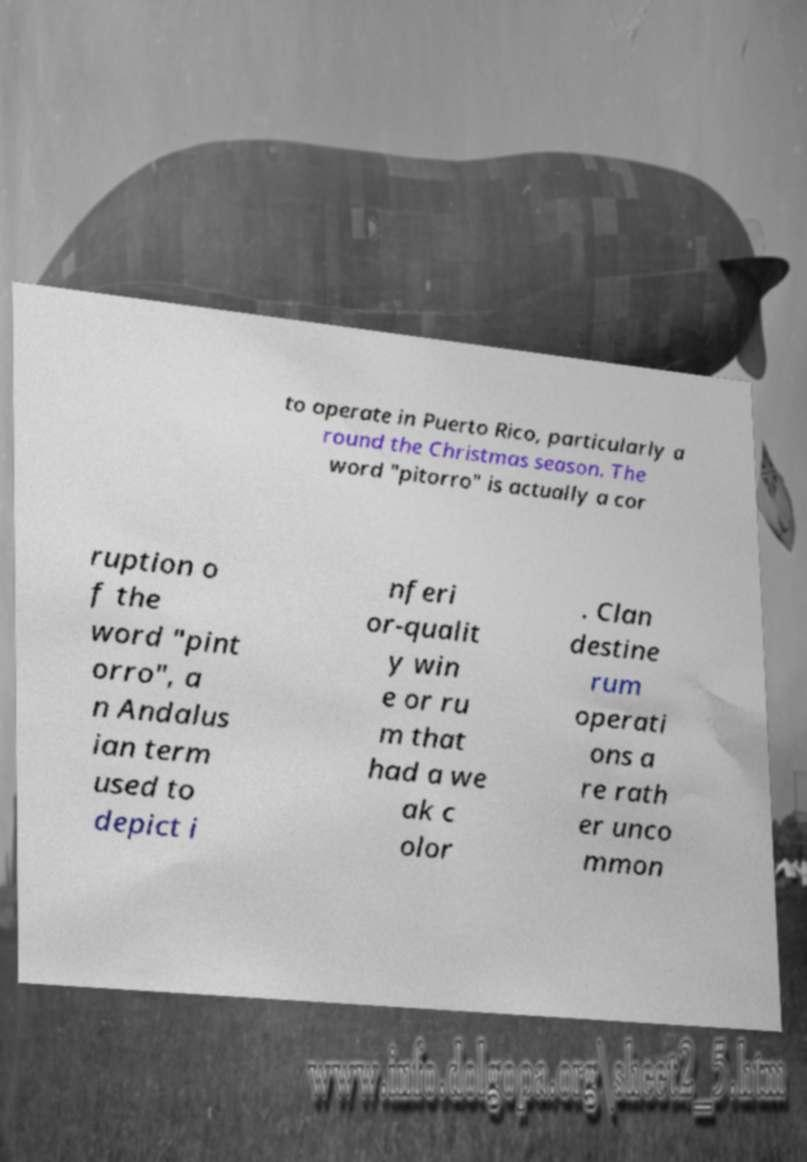Could you extract and type out the text from this image? to operate in Puerto Rico, particularly a round the Christmas season. The word "pitorro" is actually a cor ruption o f the word "pint orro", a n Andalus ian term used to depict i nferi or-qualit y win e or ru m that had a we ak c olor . Clan destine rum operati ons a re rath er unco mmon 